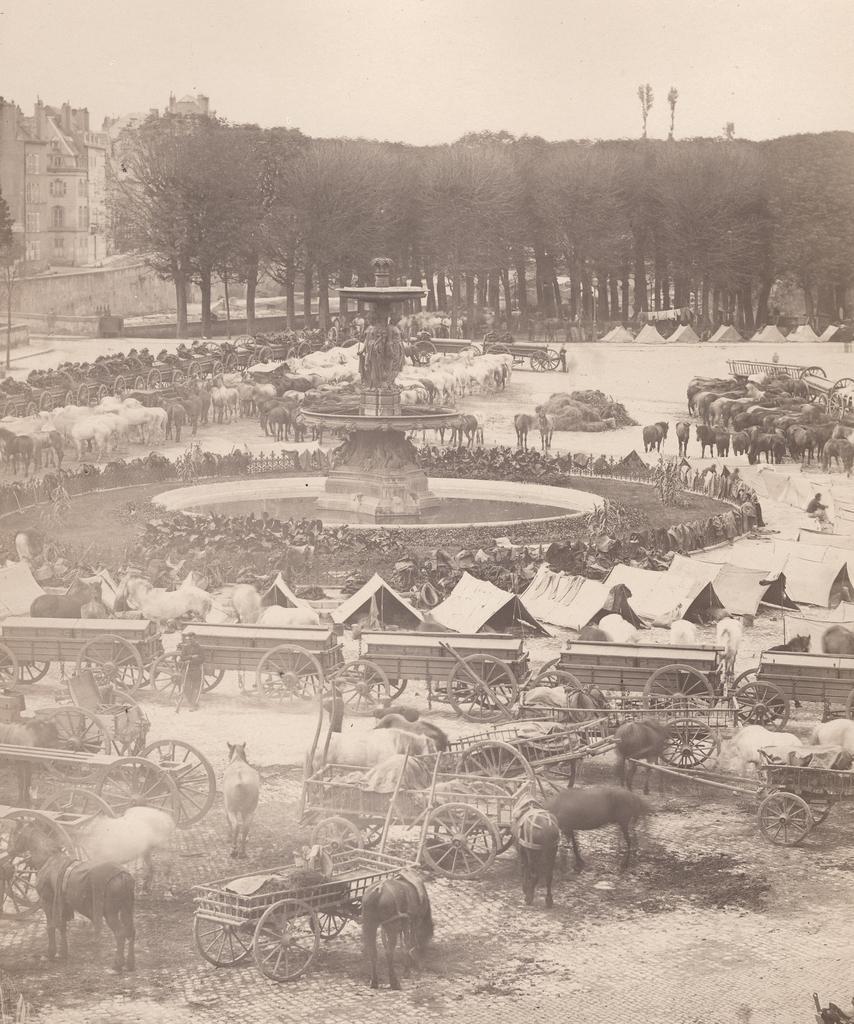Please provide a concise description of this image. In this image there are few buildings, trees, animals, carts, a fountain, sculptures and the sky. 